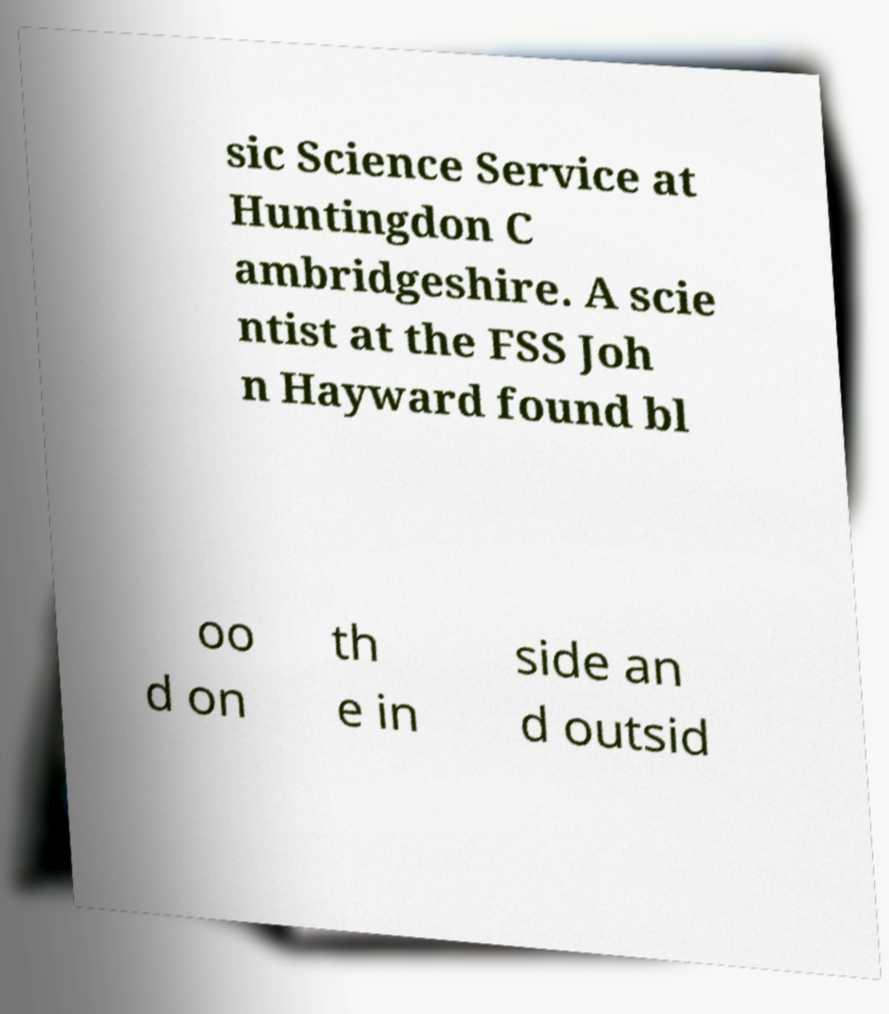Please identify and transcribe the text found in this image. sic Science Service at Huntingdon C ambridgeshire. A scie ntist at the FSS Joh n Hayward found bl oo d on th e in side an d outsid 